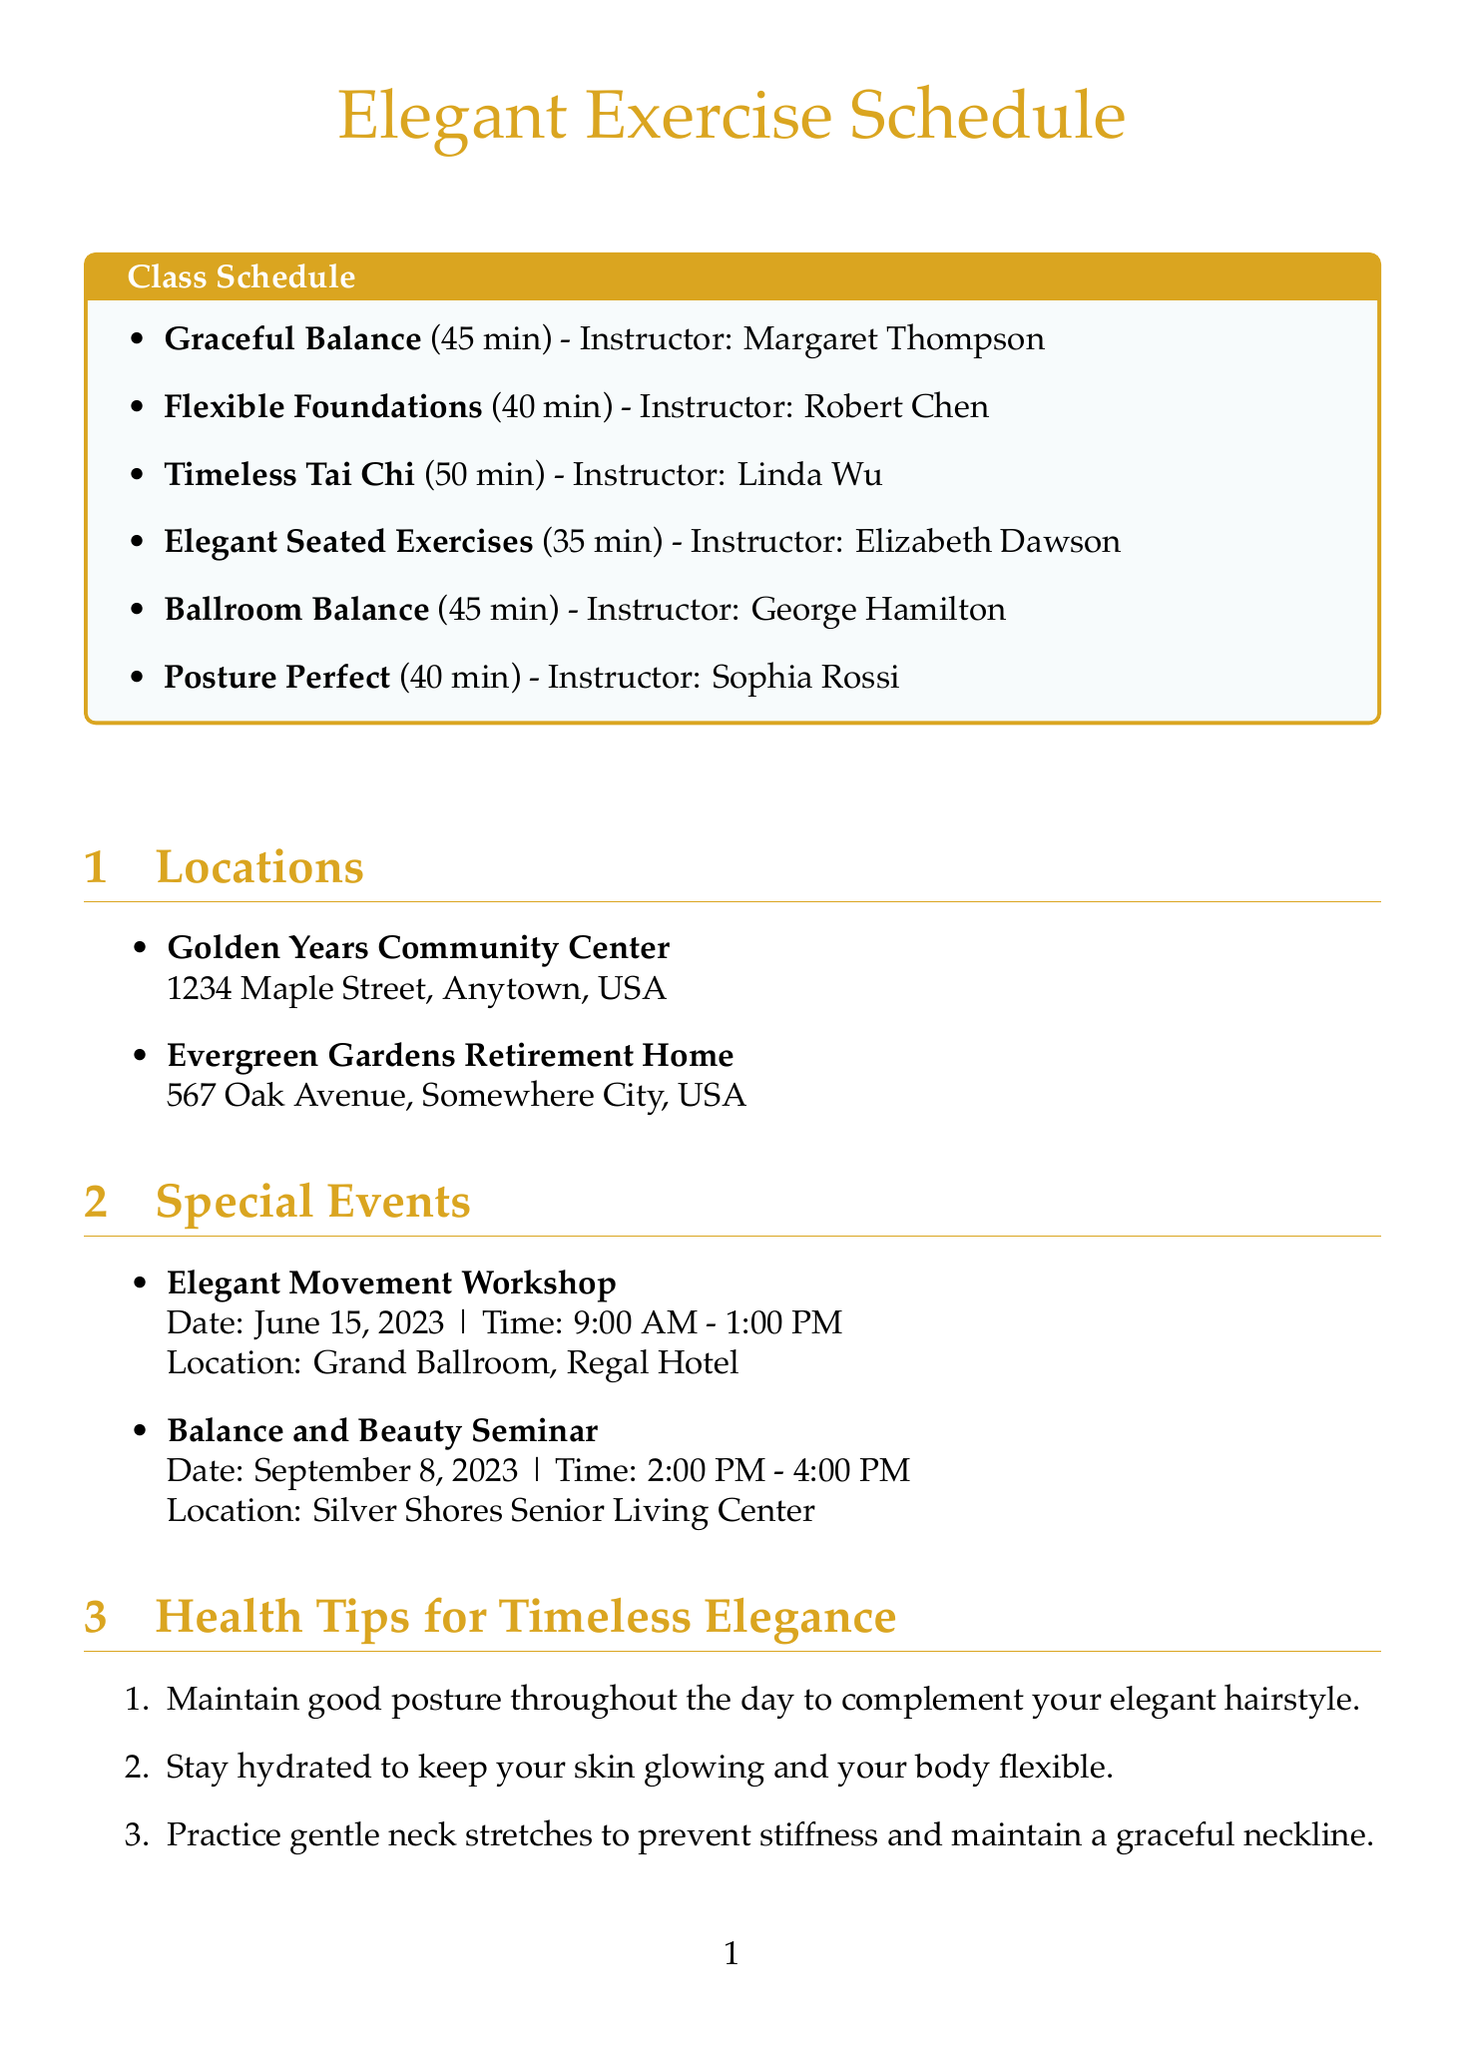What are the names of the classes? The class names are listed under the Class Schedule section.
Answer: Graceful Balance, Flexible Foundations, Timeless Tai Chi, Elegant Seated Exercises, Ballroom Balance, Posture Perfect Who is the instructor for Timeless Tai Chi? The instructor's name is provided next to each class in the Class Schedule section.
Answer: Linda Wu What is the duration of Flexible Foundations? The duration is noted beside each class in the Class Schedule section.
Answer: 40 minutes Where will the Elegant Movement Workshop be held? The location is specified in the Special Events section of the document.
Answer: Grand Ballroom, Regal Hotel How many minutes does the Elegant Seated Exercises class last? The duration is indicated next to the class name in the Class Schedule.
Answer: 35 minutes What health tip suggests staying hydrated? It's one of the health tips listed under the Health Tips for Timeless Elegance section.
Answer: Stay hydrated to keep your skin glowing and your body flexible Which facility offers on-site parking? The amenities for each location are stated under the Locations section.
Answer: Evergreen Gardens Retirement Home What type of exercises does Ballroom Balance combine? This is described in the class description, indicating its content.
Answer: Ballroom dancing with balance exercises What is the date of the Balance and Beauty Seminar? The special event's date is listed in the Special Events section.
Answer: September 8, 2023 